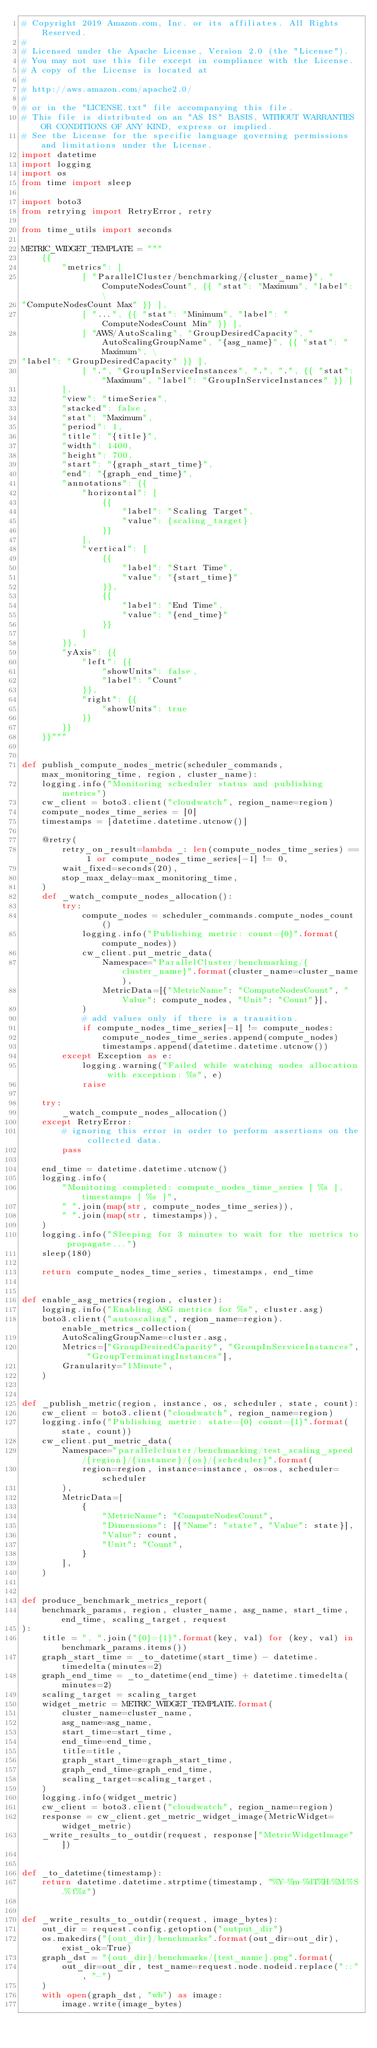Convert code to text. <code><loc_0><loc_0><loc_500><loc_500><_Python_># Copyright 2019 Amazon.com, Inc. or its affiliates. All Rights Reserved.
#
# Licensed under the Apache License, Version 2.0 (the "License").
# You may not use this file except in compliance with the License.
# A copy of the License is located at
#
# http://aws.amazon.com/apache2.0/
#
# or in the "LICENSE.txt" file accompanying this file.
# This file is distributed on an "AS IS" BASIS, WITHOUT WARRANTIES OR CONDITIONS OF ANY KIND, express or implied.
# See the License for the specific language governing permissions and limitations under the License.
import datetime
import logging
import os
from time import sleep

import boto3
from retrying import RetryError, retry

from time_utils import seconds

METRIC_WIDGET_TEMPLATE = """
    {{
        "metrics": [
            [ "ParallelCluster/benchmarking/{cluster_name}", "ComputeNodesCount", {{ "stat": "Maximum", "label": \
"ComputeNodesCount Max" }} ],
            [ "...", {{ "stat": "Minimum", "label": "ComputeNodesCount Min" }} ],
            [ "AWS/AutoScaling", "GroupDesiredCapacity", "AutoScalingGroupName", "{asg_name}", {{ "stat": "Maximum", \
"label": "GroupDesiredCapacity" }} ],
            [ ".", "GroupInServiceInstances", ".", ".", {{ "stat": "Maximum", "label": "GroupInServiceInstances" }} ]
        ],
        "view": "timeSeries",
        "stacked": false,
        "stat": "Maximum",
        "period": 1,
        "title": "{title}",
        "width": 1400,
        "height": 700,
        "start": "{graph_start_time}",
        "end": "{graph_end_time}",
        "annotations": {{
            "horizontal": [
                {{
                    "label": "Scaling Target",
                    "value": {scaling_target}
                }}
            ],
            "vertical": [
                {{
                    "label": "Start Time",
                    "value": "{start_time}"
                }},
                {{
                    "label": "End Time",
                    "value": "{end_time}"
                }}
            ]
        }},
        "yAxis": {{
            "left": {{
                "showUnits": false,
                "label": "Count"
            }},
            "right": {{
                "showUnits": true
            }}
        }}
    }}"""


def publish_compute_nodes_metric(scheduler_commands, max_monitoring_time, region, cluster_name):
    logging.info("Monitoring scheduler status and publishing metrics")
    cw_client = boto3.client("cloudwatch", region_name=region)
    compute_nodes_time_series = [0]
    timestamps = [datetime.datetime.utcnow()]

    @retry(
        retry_on_result=lambda _: len(compute_nodes_time_series) == 1 or compute_nodes_time_series[-1] != 0,
        wait_fixed=seconds(20),
        stop_max_delay=max_monitoring_time,
    )
    def _watch_compute_nodes_allocation():
        try:
            compute_nodes = scheduler_commands.compute_nodes_count()
            logging.info("Publishing metric: count={0}".format(compute_nodes))
            cw_client.put_metric_data(
                Namespace="ParallelCluster/benchmarking/{cluster_name}".format(cluster_name=cluster_name),
                MetricData=[{"MetricName": "ComputeNodesCount", "Value": compute_nodes, "Unit": "Count"}],
            )
            # add values only if there is a transition.
            if compute_nodes_time_series[-1] != compute_nodes:
                compute_nodes_time_series.append(compute_nodes)
                timestamps.append(datetime.datetime.utcnow())
        except Exception as e:
            logging.warning("Failed while watching nodes allocation with exception: %s", e)
            raise

    try:
        _watch_compute_nodes_allocation()
    except RetryError:
        # ignoring this error in order to perform assertions on the collected data.
        pass

    end_time = datetime.datetime.utcnow()
    logging.info(
        "Monitoring completed: compute_nodes_time_series [ %s ], timestamps [ %s ]",
        " ".join(map(str, compute_nodes_time_series)),
        " ".join(map(str, timestamps)),
    )
    logging.info("Sleeping for 3 minutes to wait for the metrics to propagate...")
    sleep(180)

    return compute_nodes_time_series, timestamps, end_time


def enable_asg_metrics(region, cluster):
    logging.info("Enabling ASG metrics for %s", cluster.asg)
    boto3.client("autoscaling", region_name=region).enable_metrics_collection(
        AutoScalingGroupName=cluster.asg,
        Metrics=["GroupDesiredCapacity", "GroupInServiceInstances", "GroupTerminatingInstances"],
        Granularity="1Minute",
    )


def _publish_metric(region, instance, os, scheduler, state, count):
    cw_client = boto3.client("cloudwatch", region_name=region)
    logging.info("Publishing metric: state={0} count={1}".format(state, count))
    cw_client.put_metric_data(
        Namespace="parallelcluster/benchmarking/test_scaling_speed/{region}/{instance}/{os}/{scheduler}".format(
            region=region, instance=instance, os=os, scheduler=scheduler
        ),
        MetricData=[
            {
                "MetricName": "ComputeNodesCount",
                "Dimensions": [{"Name": "state", "Value": state}],
                "Value": count,
                "Unit": "Count",
            }
        ],
    )


def produce_benchmark_metrics_report(
    benchmark_params, region, cluster_name, asg_name, start_time, end_time, scaling_target, request
):
    title = ", ".join("{0}={1}".format(key, val) for (key, val) in benchmark_params.items())
    graph_start_time = _to_datetime(start_time) - datetime.timedelta(minutes=2)
    graph_end_time = _to_datetime(end_time) + datetime.timedelta(minutes=2)
    scaling_target = scaling_target
    widget_metric = METRIC_WIDGET_TEMPLATE.format(
        cluster_name=cluster_name,
        asg_name=asg_name,
        start_time=start_time,
        end_time=end_time,
        title=title,
        graph_start_time=graph_start_time,
        graph_end_time=graph_end_time,
        scaling_target=scaling_target,
    )
    logging.info(widget_metric)
    cw_client = boto3.client("cloudwatch", region_name=region)
    response = cw_client.get_metric_widget_image(MetricWidget=widget_metric)
    _write_results_to_outdir(request, response["MetricWidgetImage"])


def _to_datetime(timestamp):
    return datetime.datetime.strptime(timestamp, "%Y-%m-%dT%H:%M:%S.%f%z")


def _write_results_to_outdir(request, image_bytes):
    out_dir = request.config.getoption("output_dir")
    os.makedirs("{out_dir}/benchmarks".format(out_dir=out_dir), exist_ok=True)
    graph_dst = "{out_dir}/benchmarks/{test_name}.png".format(
        out_dir=out_dir, test_name=request.node.nodeid.replace("::", "-")
    )
    with open(graph_dst, "wb") as image:
        image.write(image_bytes)
</code> 